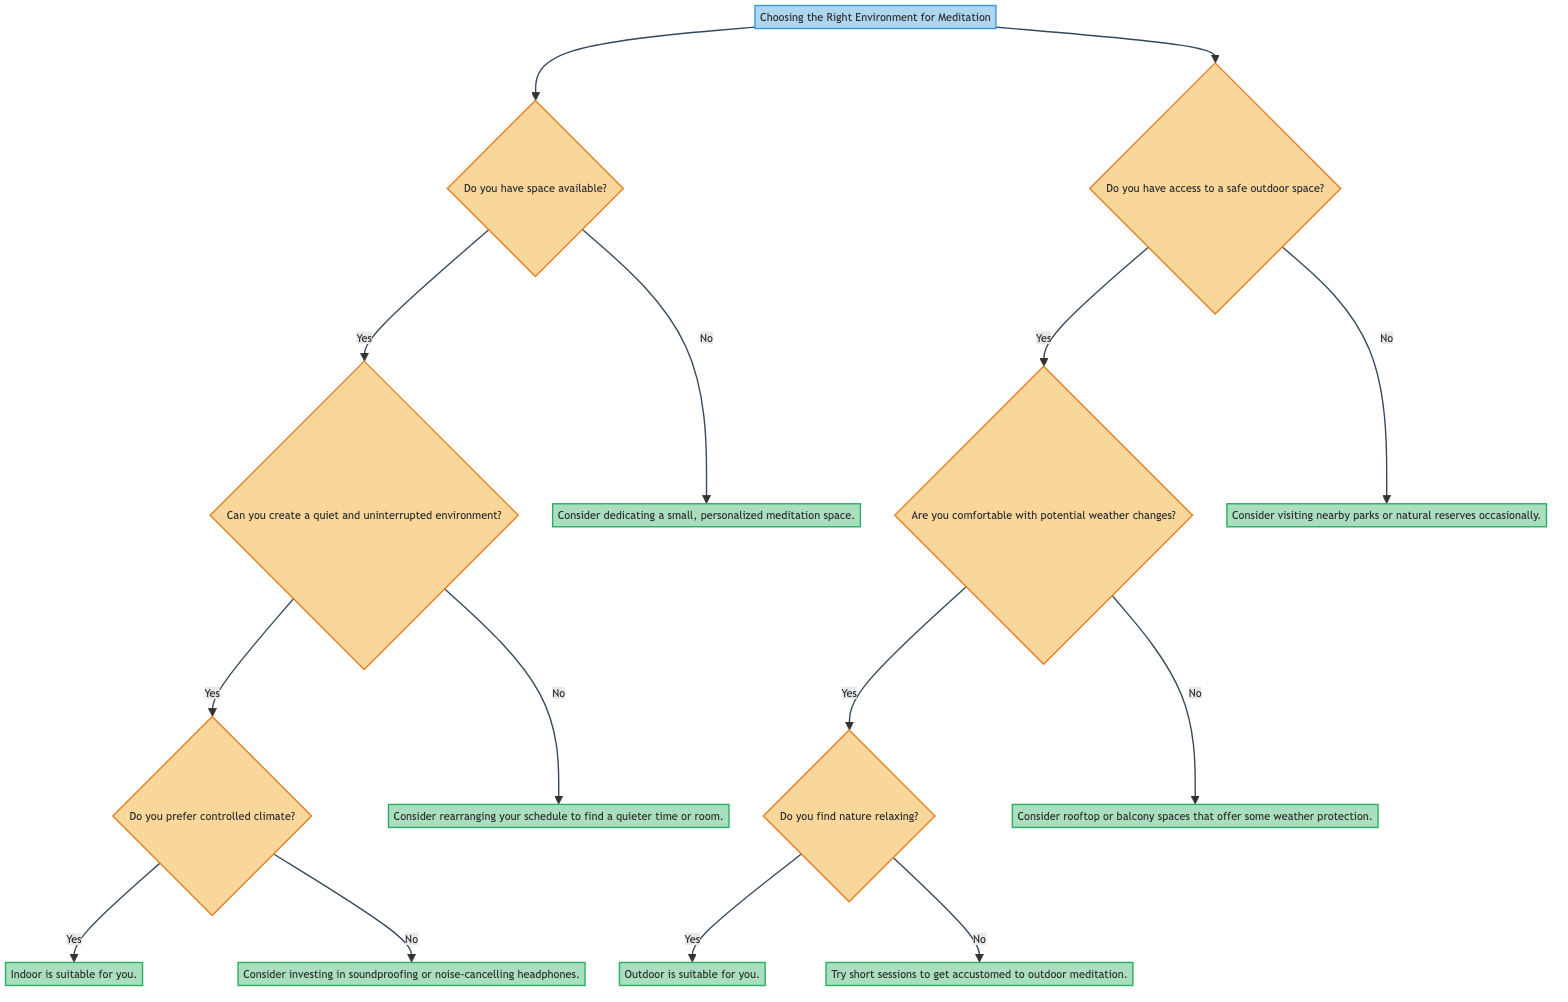What is the main decision in this diagram? The main decision indicated at the top of the diagram is about "Choosing the Right Environment for Meditation." This is the starting point of the decision tree, and it branches out into two main options: Indoor and Outdoor.
Answer: Choosing the Right Environment for Meditation How many nodes are in the Indoor section? In the Indoor section, starting from the initial node for choosing indoor, there are four nodes (B, C, D, E) that represent conditions and outcomes.
Answer: 4 What happens if you do not have space available for indoor meditation? If there is no space available, the response points to dedicating a small, personalized meditation space, indicating that even limited space can be utilized effectively.
Answer: Consider dedicating a small, personalized meditation space Is there an outcome if you are not comfortable with potential weather changes outdoors? Yes, if you are not comfortable with potential weather changes when considering outdoor meditation, the outcome suggests checking rooftop or balcony spaces for some weather protection, indicating a compromise in outdoor options.
Answer: Consider rooftop or balcony spaces that offer some weather protection What do you do if you find nature relaxing and have access to a safe outdoor space? If you find nature relaxing and have access to a safe outdoor space, the diagram indicates that outdoor meditation is suitable for you, implying that it is a favorable choice.
Answer: Outdoor is suitable for you What should you consider if you have access to a safe outdoor space but do not find nature relaxing? If you have access to a safe outdoor space but do not find nature relaxing, the suggestion is to try short sessions to get accustomed to outdoor meditation, indicating a gentle introduction to this environment.
Answer: Try short sessions to get accustomed to outdoor meditation What is recommended if you cannot create a quiet and uninterrupted indoor environment? If you cannot create a quiet and uninterrupted indoor environment, the recommendation is to rearrange your schedule to find a quieter time or room, suggesting the importance of a peaceful atmosphere for meditation.
Answer: Consider rearranging your schedule to find a quieter time or room Do you need to invest in soundproofing if you prefer controlled climate indoors? If you prefer a controlled climate indoors and cannot create a quiet environment, then the recommendation is to consider investing in soundproofing or noise-cancelling headphones, indicating a solution to external disturbances.
Answer: Consider investing in soundproofing or noise-cancelling headphones 